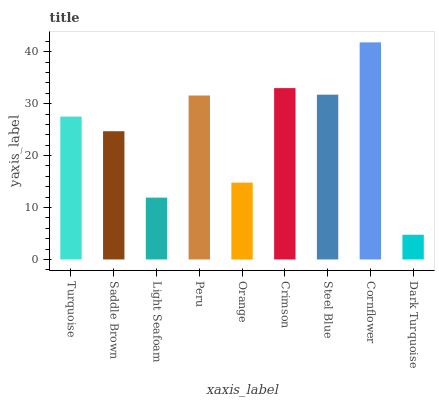Is Dark Turquoise the minimum?
Answer yes or no. Yes. Is Cornflower the maximum?
Answer yes or no. Yes. Is Saddle Brown the minimum?
Answer yes or no. No. Is Saddle Brown the maximum?
Answer yes or no. No. Is Turquoise greater than Saddle Brown?
Answer yes or no. Yes. Is Saddle Brown less than Turquoise?
Answer yes or no. Yes. Is Saddle Brown greater than Turquoise?
Answer yes or no. No. Is Turquoise less than Saddle Brown?
Answer yes or no. No. Is Turquoise the high median?
Answer yes or no. Yes. Is Turquoise the low median?
Answer yes or no. Yes. Is Saddle Brown the high median?
Answer yes or no. No. Is Saddle Brown the low median?
Answer yes or no. No. 